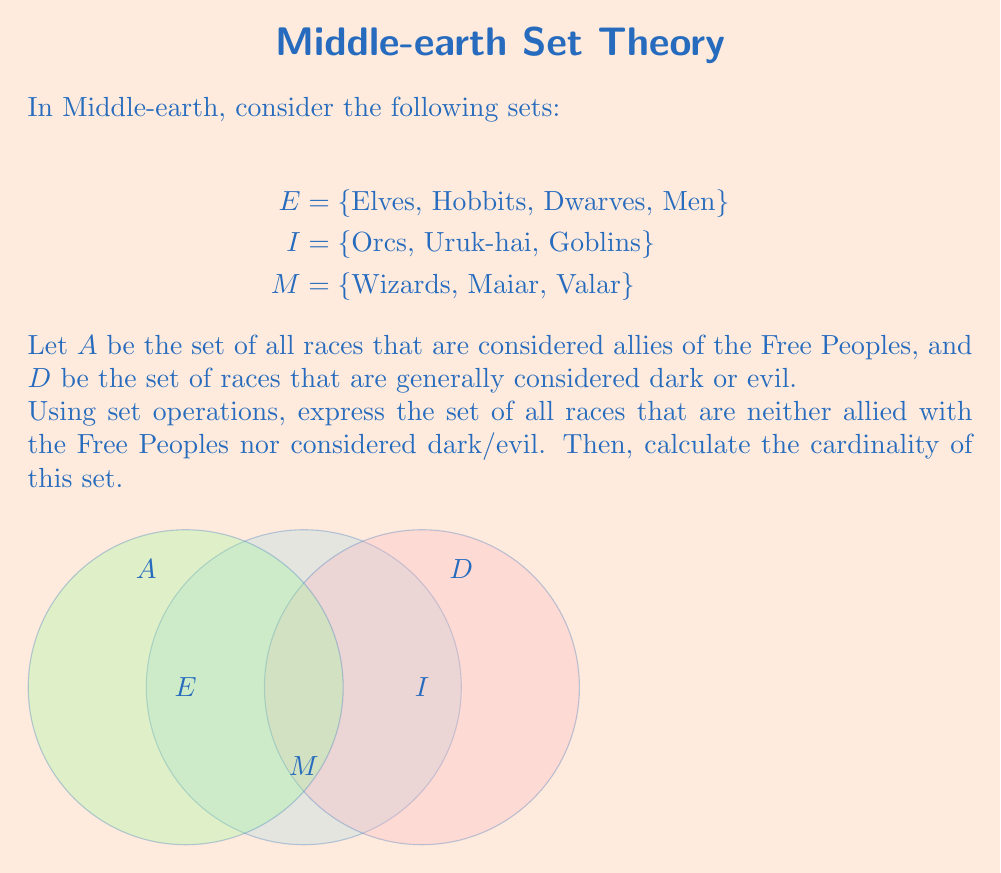Solve this math problem. Let's approach this step-by-step:

1) First, we need to determine the sets $A$ and $D$:
   $A = E$ (Elves, Hobbits, Dwarves, and Men are allies of the Free Peoples)
   $D = I$ (Orcs, Uruk-hai, and Goblins are considered dark/evil)

2) The universal set $U$ in this context is the union of all races:
   $U = E \cup I \cup M$

3) To find the races that are neither allied with the Free Peoples nor considered dark/evil, we need to find the complement of the union of $A$ and $D$:
   $$(A \cup D)^c$$

4) This can be expressed as:
   $U - (A \cup D)$

5) Substituting the sets:
   $(E \cup I \cup M) - (E \cup I)$

6) Simplifying:
   $M$ (since $E$ and $I$ are removed)

7) Therefore, the set of races neither allied with the Free Peoples nor considered dark/evil is $M$.

8) The cardinality of set $M$ is:
   $|M| = |\{Wizards, Maiar, Valar\}| = 3$
Answer: $|M| = 3$ 